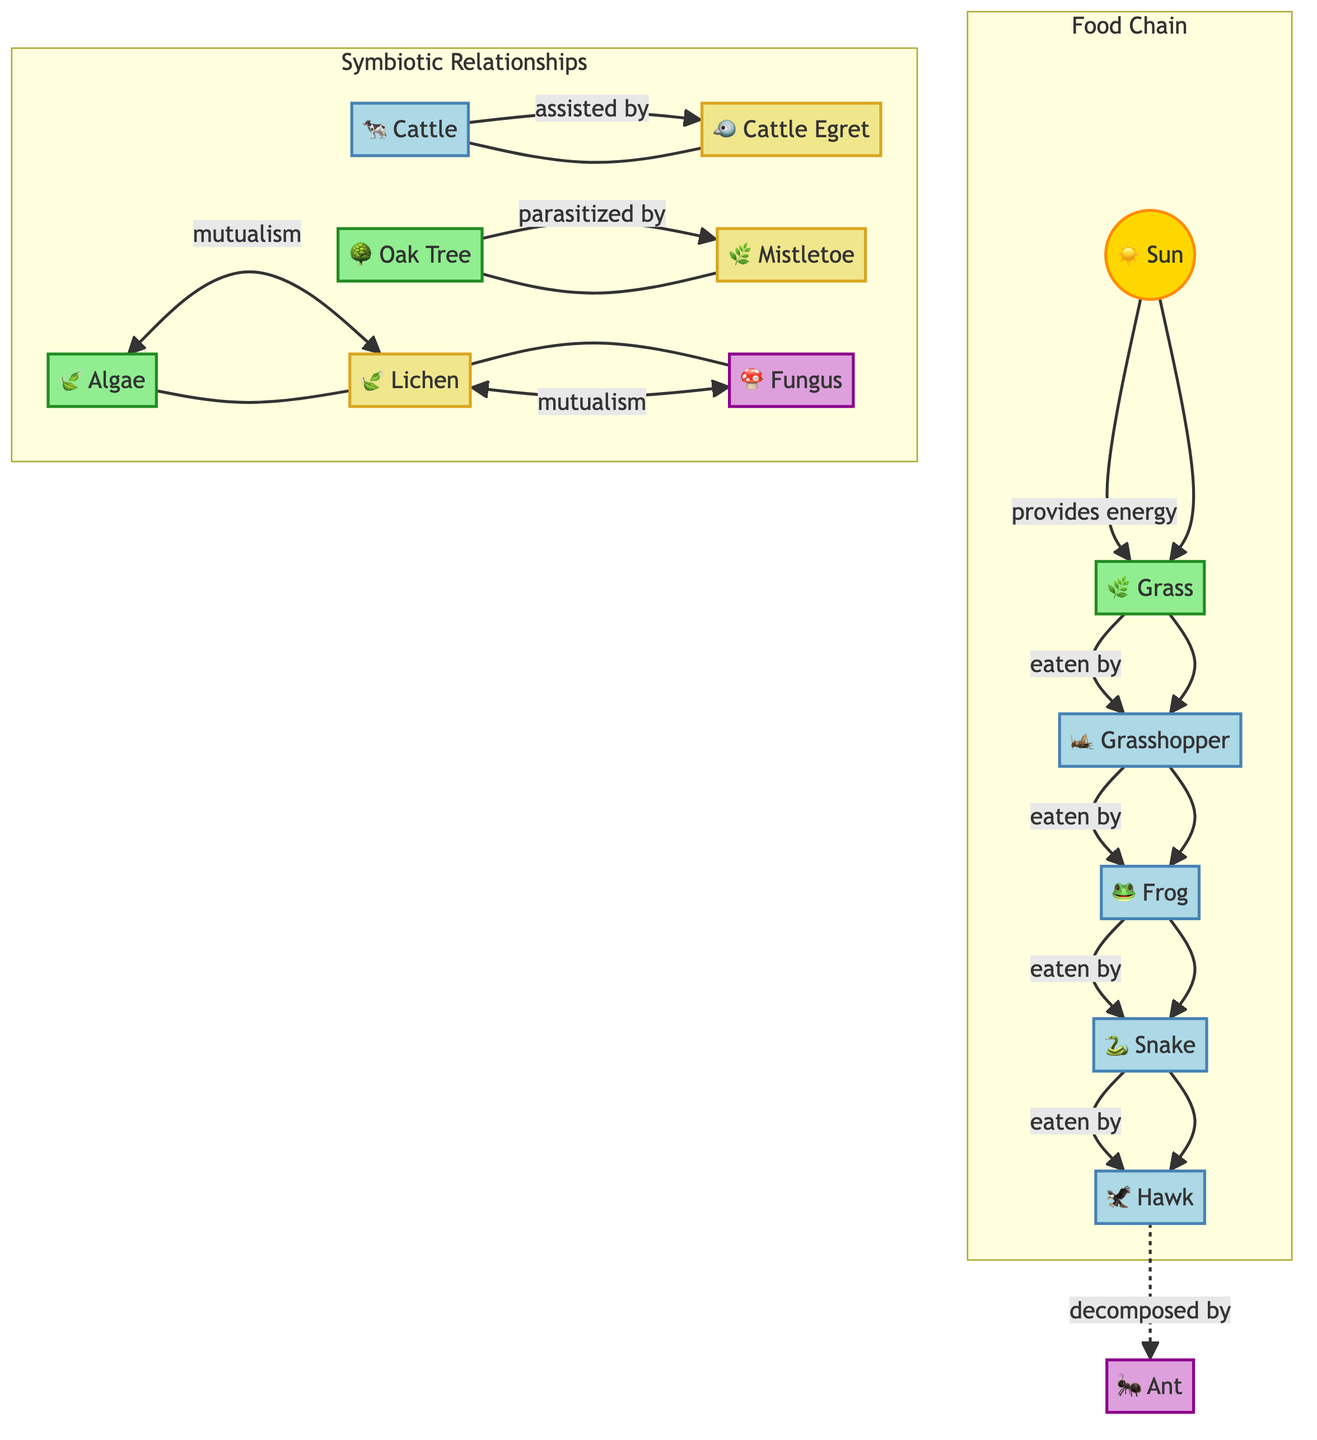What is the first node in the food chain? The first node is "☀️ Sun," which provides energy to the rest of the food chain.
Answer: ☀️ Sun How many consumers are present in the food chain? The consumers identified in the diagram are grasshopper, frog, snake, and hawk, totaling four consumers.
Answer: 4 What relationship exists between cattle and cattle egret? The diagram shows that cattle are assisted by cattle egret, a type of mutualistic relationship.
Answer: assisted Which organism is parasitized by mistletoe? The diagram indicates that the oak tree is the organism that is parasitized by mistletoe.
Answer: oak tree Which symbiotic relationship involves lichen? The diagram illustrates that lichen mutually interacts with both algae and fungus.
Answer: mutualism What role does the ant play in the food chain? In the food chain, ants are represented as decomposers, highlighting their role in breaking down organic materials.
Answer: decomposer What is the ultimate consumer in this food chain? The top-level consumer in the food chain is the hawk, which is positioned at the end of the food chain.
Answer: hawk How many nodes are in the symbiotic relationships section? There are four nodes in the symbiotic relationships section, which are cattle, cattle egret, oak tree, and mistletoe, algae, lichen, and fungus.
Answer: 7 What type of relationship exists between algae and lichen? According to the diagram, the relationship between algae and lichen is expressed as mutualism.
Answer: mutualism 